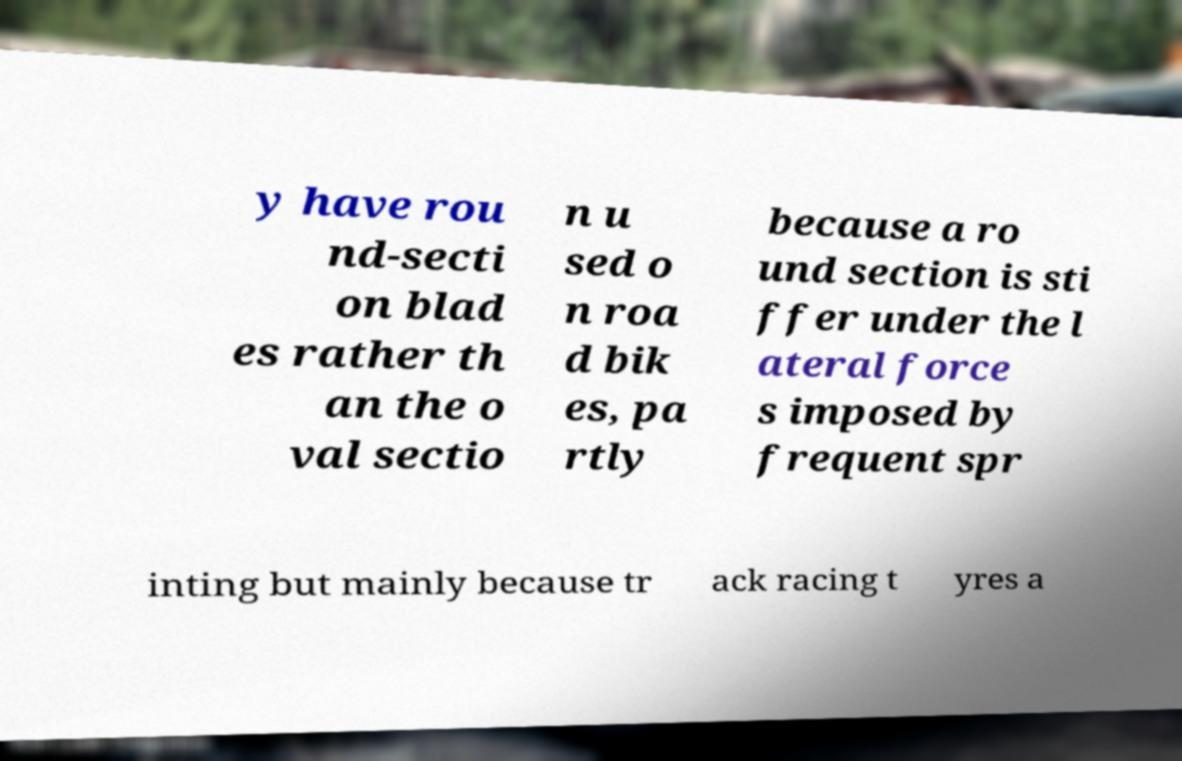Can you accurately transcribe the text from the provided image for me? y have rou nd-secti on blad es rather th an the o val sectio n u sed o n roa d bik es, pa rtly because a ro und section is sti ffer under the l ateral force s imposed by frequent spr inting but mainly because tr ack racing t yres a 